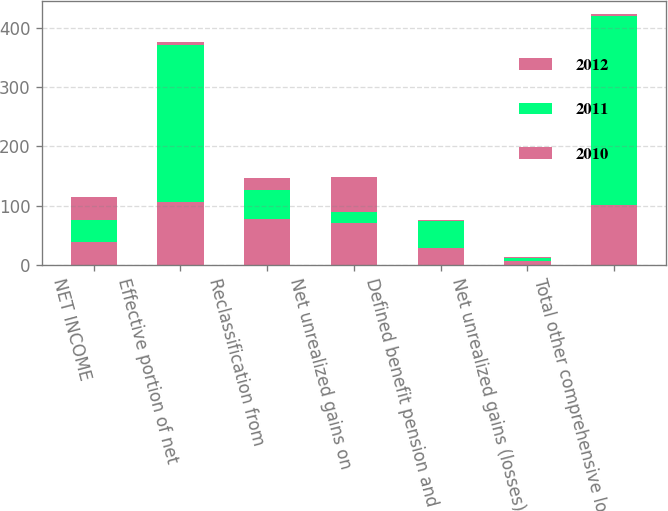Convert chart to OTSL. <chart><loc_0><loc_0><loc_500><loc_500><stacked_bar_chart><ecel><fcel>NET INCOME<fcel>Effective portion of net<fcel>Reclassification from<fcel>Net unrealized gains on<fcel>Defined benefit pension and<fcel>Net unrealized gains (losses)<fcel>Total other comprehensive loss<nl><fcel>2012<fcel>38<fcel>106<fcel>77<fcel>70<fcel>28<fcel>7<fcel>101<nl><fcel>2011<fcel>38<fcel>265<fcel>49<fcel>19<fcel>45<fcel>5<fcel>320<nl><fcel>2010<fcel>38<fcel>5<fcel>21<fcel>60<fcel>2<fcel>1<fcel>3<nl></chart> 